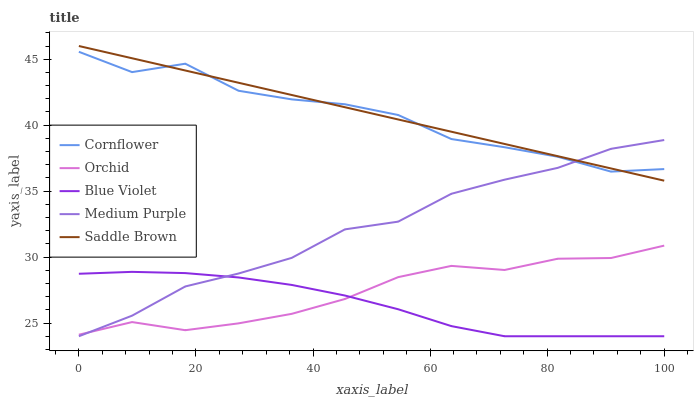Does Cornflower have the minimum area under the curve?
Answer yes or no. No. Does Cornflower have the maximum area under the curve?
Answer yes or no. No. Is Cornflower the smoothest?
Answer yes or no. No. Is Saddle Brown the roughest?
Answer yes or no. No. Does Saddle Brown have the lowest value?
Answer yes or no. No. Does Cornflower have the highest value?
Answer yes or no. No. Is Orchid less than Cornflower?
Answer yes or no. Yes. Is Saddle Brown greater than Orchid?
Answer yes or no. Yes. Does Orchid intersect Cornflower?
Answer yes or no. No. 